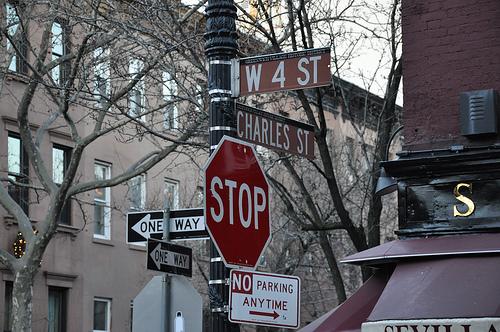What is this intersection the corner of?
Keep it brief. W 4 st and charles st. What season was this picture taken in?
Write a very short answer. Winter. When can you park in the area depicted in this photo?
Keep it brief. Never. 